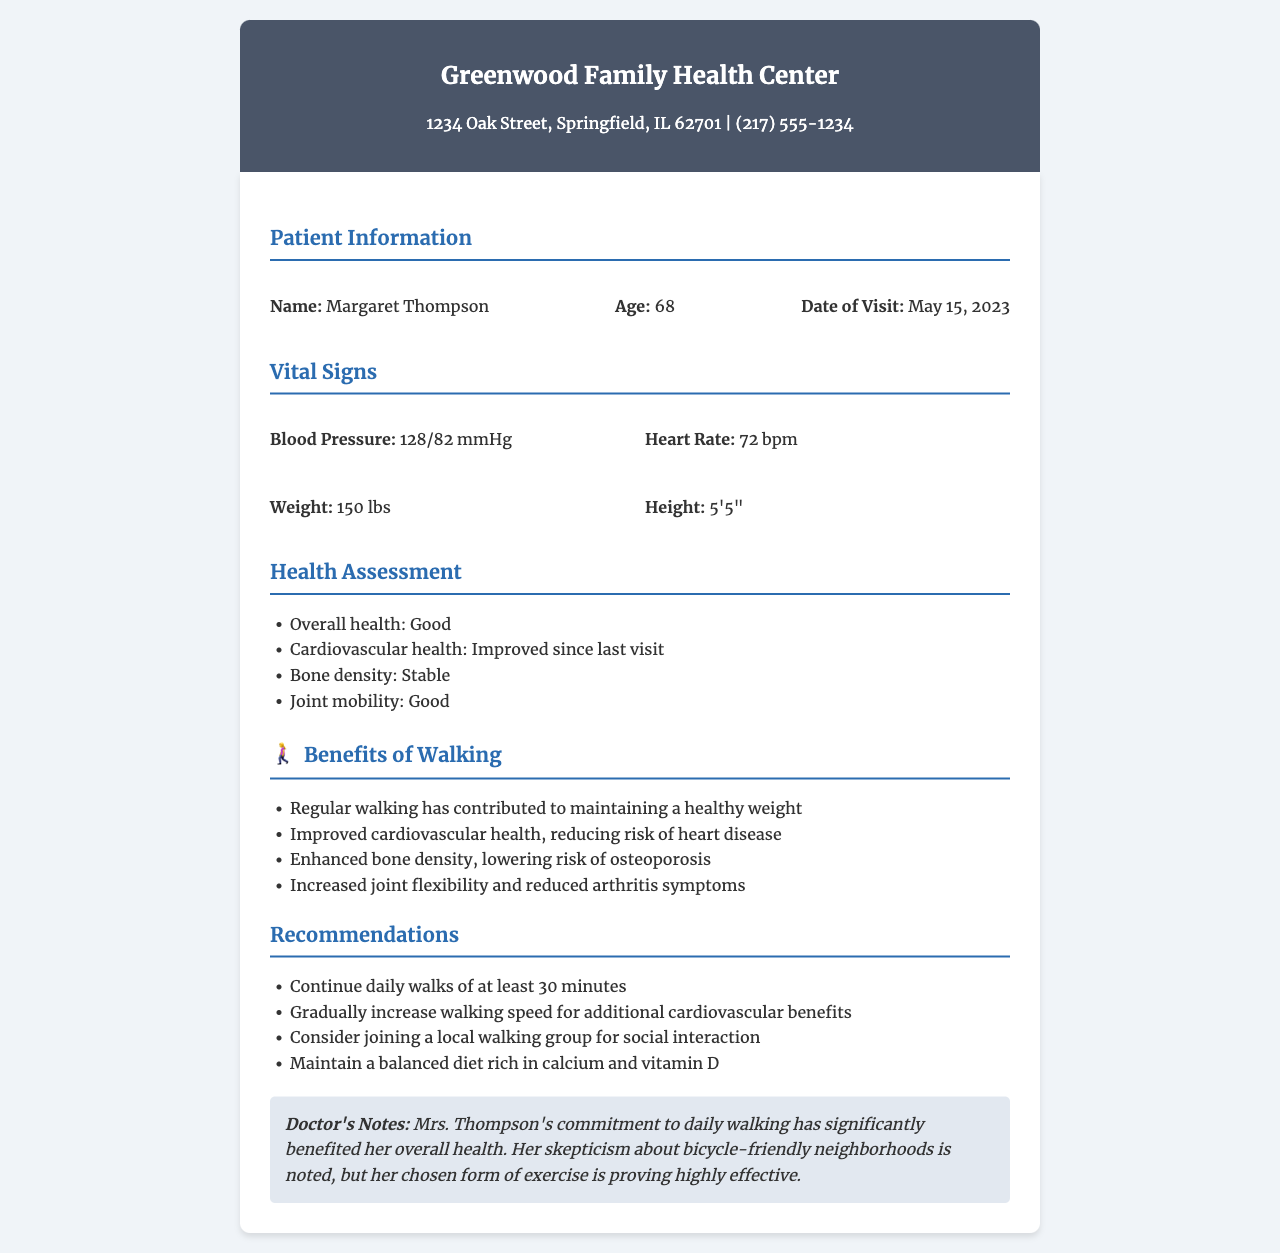What is the name of the patient? The patient's name is listed at the beginning of the patient information section.
Answer: Margaret Thompson What is the patient's age? The patient's age can be found in the patient information section of the document.
Answer: 68 What is the blood pressure recorded in the report? The blood pressure information is provided under the vital signs section.
Answer: 128/82 mmHg How many minutes should the patient walk daily? The recommendation section specifies the duration of daily walks.
Answer: 30 minutes What health aspect improved since the last visit? The health assessment mentions improvements in cardiovascular health specifically.
Answer: Cardiovascular health What benefits of walking are listed? The benefits of walking are detailed in a dedicated section of the document.
Answer: Maintained a healthy weight, improved cardiovascular health, enhanced bone density, increased joint flexibility What does the doctor note about Mrs. Thompson's exercise choice? The doctor's notes provide insight into the effectiveness of Mrs. Thompson's chosen exercise form.
Answer: Highly effective What is one recommendation for the patient besides walking? Recommendations in the document list various ways to complement walking and improve health.
Answer: Join a local walking group for social interaction 